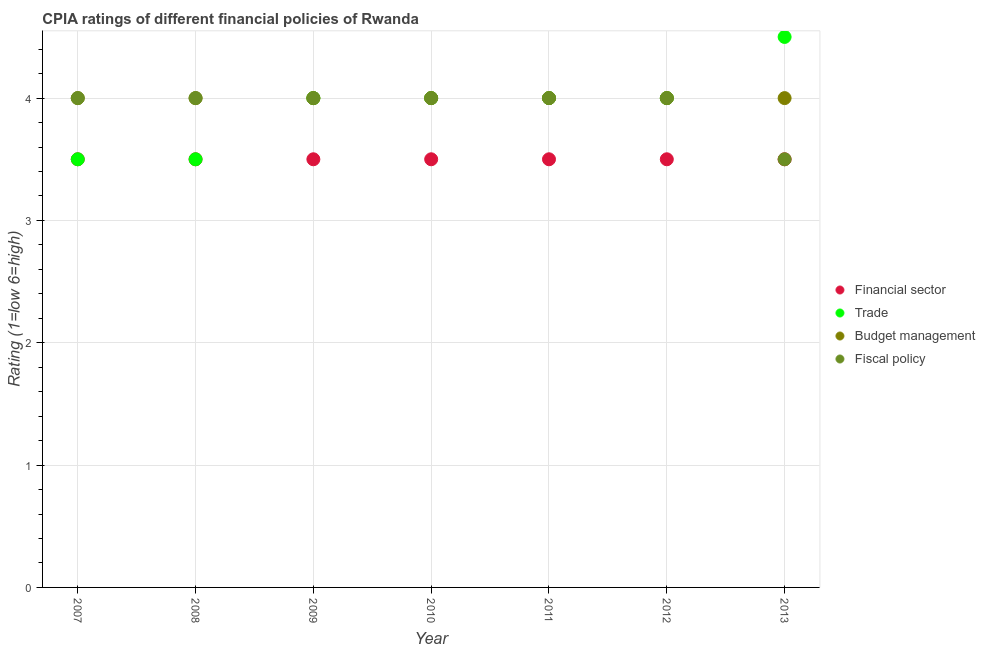How many different coloured dotlines are there?
Your response must be concise. 4. Across all years, what is the minimum cpia rating of trade?
Offer a terse response. 3.5. In which year was the cpia rating of budget management maximum?
Offer a very short reply. 2007. What is the average cpia rating of fiscal policy per year?
Make the answer very short. 3.93. Is it the case that in every year, the sum of the cpia rating of fiscal policy and cpia rating of trade is greater than the sum of cpia rating of financial sector and cpia rating of budget management?
Ensure brevity in your answer.  No. Is it the case that in every year, the sum of the cpia rating of financial sector and cpia rating of trade is greater than the cpia rating of budget management?
Your response must be concise. Yes. Is the cpia rating of fiscal policy strictly greater than the cpia rating of trade over the years?
Your answer should be very brief. No. Is the cpia rating of financial sector strictly less than the cpia rating of fiscal policy over the years?
Ensure brevity in your answer.  No. How many years are there in the graph?
Offer a very short reply. 7. What is the difference between two consecutive major ticks on the Y-axis?
Keep it short and to the point. 1. Does the graph contain any zero values?
Make the answer very short. No. Does the graph contain grids?
Offer a very short reply. Yes. Where does the legend appear in the graph?
Make the answer very short. Center right. What is the title of the graph?
Keep it short and to the point. CPIA ratings of different financial policies of Rwanda. Does "Minerals" appear as one of the legend labels in the graph?
Ensure brevity in your answer.  No. What is the label or title of the X-axis?
Your answer should be compact. Year. What is the label or title of the Y-axis?
Your answer should be very brief. Rating (1=low 6=high). What is the Rating (1=low 6=high) of Trade in 2007?
Your answer should be compact. 3.5. What is the Rating (1=low 6=high) in Fiscal policy in 2007?
Your response must be concise. 4. What is the Rating (1=low 6=high) of Fiscal policy in 2008?
Provide a short and direct response. 4. What is the Rating (1=low 6=high) of Trade in 2009?
Keep it short and to the point. 4. What is the Rating (1=low 6=high) of Fiscal policy in 2009?
Keep it short and to the point. 4. What is the Rating (1=low 6=high) of Trade in 2010?
Ensure brevity in your answer.  4. What is the Rating (1=low 6=high) in Fiscal policy in 2010?
Make the answer very short. 4. What is the Rating (1=low 6=high) in Trade in 2012?
Provide a short and direct response. 4. What is the Rating (1=low 6=high) in Budget management in 2013?
Offer a terse response. 4. Across all years, what is the minimum Rating (1=low 6=high) in Fiscal policy?
Your answer should be compact. 3.5. What is the total Rating (1=low 6=high) of Trade in the graph?
Provide a short and direct response. 27.5. What is the total Rating (1=low 6=high) of Budget management in the graph?
Keep it short and to the point. 28. What is the total Rating (1=low 6=high) of Fiscal policy in the graph?
Ensure brevity in your answer.  27.5. What is the difference between the Rating (1=low 6=high) in Financial sector in 2007 and that in 2008?
Provide a succinct answer. 0. What is the difference between the Rating (1=low 6=high) in Trade in 2007 and that in 2008?
Your answer should be very brief. 0. What is the difference between the Rating (1=low 6=high) of Budget management in 2007 and that in 2008?
Keep it short and to the point. 0. What is the difference between the Rating (1=low 6=high) in Fiscal policy in 2007 and that in 2008?
Keep it short and to the point. 0. What is the difference between the Rating (1=low 6=high) in Financial sector in 2007 and that in 2009?
Provide a short and direct response. 0. What is the difference between the Rating (1=low 6=high) of Trade in 2007 and that in 2009?
Your answer should be very brief. -0.5. What is the difference between the Rating (1=low 6=high) in Fiscal policy in 2007 and that in 2009?
Offer a very short reply. 0. What is the difference between the Rating (1=low 6=high) of Budget management in 2007 and that in 2011?
Your answer should be compact. 0. What is the difference between the Rating (1=low 6=high) in Trade in 2007 and that in 2012?
Give a very brief answer. -0.5. What is the difference between the Rating (1=low 6=high) of Financial sector in 2007 and that in 2013?
Give a very brief answer. 0. What is the difference between the Rating (1=low 6=high) of Trade in 2007 and that in 2013?
Your answer should be compact. -1. What is the difference between the Rating (1=low 6=high) of Budget management in 2008 and that in 2009?
Ensure brevity in your answer.  0. What is the difference between the Rating (1=low 6=high) of Fiscal policy in 2008 and that in 2009?
Offer a terse response. 0. What is the difference between the Rating (1=low 6=high) in Financial sector in 2008 and that in 2010?
Provide a short and direct response. 0. What is the difference between the Rating (1=low 6=high) in Budget management in 2008 and that in 2010?
Your answer should be very brief. 0. What is the difference between the Rating (1=low 6=high) of Financial sector in 2008 and that in 2011?
Keep it short and to the point. 0. What is the difference between the Rating (1=low 6=high) of Budget management in 2008 and that in 2011?
Your response must be concise. 0. What is the difference between the Rating (1=low 6=high) in Trade in 2008 and that in 2012?
Provide a short and direct response. -0.5. What is the difference between the Rating (1=low 6=high) in Budget management in 2008 and that in 2012?
Make the answer very short. 0. What is the difference between the Rating (1=low 6=high) in Financial sector in 2009 and that in 2010?
Ensure brevity in your answer.  0. What is the difference between the Rating (1=low 6=high) in Financial sector in 2009 and that in 2011?
Provide a short and direct response. 0. What is the difference between the Rating (1=low 6=high) in Budget management in 2009 and that in 2011?
Offer a terse response. 0. What is the difference between the Rating (1=low 6=high) of Fiscal policy in 2009 and that in 2011?
Your answer should be very brief. 0. What is the difference between the Rating (1=low 6=high) of Financial sector in 2009 and that in 2012?
Make the answer very short. 0. What is the difference between the Rating (1=low 6=high) of Budget management in 2009 and that in 2012?
Your answer should be compact. 0. What is the difference between the Rating (1=low 6=high) in Fiscal policy in 2009 and that in 2012?
Offer a terse response. 0. What is the difference between the Rating (1=low 6=high) in Financial sector in 2009 and that in 2013?
Provide a short and direct response. 0. What is the difference between the Rating (1=low 6=high) in Budget management in 2009 and that in 2013?
Offer a terse response. 0. What is the difference between the Rating (1=low 6=high) in Financial sector in 2010 and that in 2012?
Your response must be concise. 0. What is the difference between the Rating (1=low 6=high) in Trade in 2010 and that in 2012?
Your response must be concise. 0. What is the difference between the Rating (1=low 6=high) in Trade in 2010 and that in 2013?
Ensure brevity in your answer.  -0.5. What is the difference between the Rating (1=low 6=high) of Budget management in 2010 and that in 2013?
Ensure brevity in your answer.  0. What is the difference between the Rating (1=low 6=high) of Fiscal policy in 2010 and that in 2013?
Ensure brevity in your answer.  0.5. What is the difference between the Rating (1=low 6=high) in Financial sector in 2011 and that in 2012?
Keep it short and to the point. 0. What is the difference between the Rating (1=low 6=high) of Fiscal policy in 2011 and that in 2012?
Provide a short and direct response. 0. What is the difference between the Rating (1=low 6=high) of Financial sector in 2012 and that in 2013?
Provide a succinct answer. 0. What is the difference between the Rating (1=low 6=high) in Financial sector in 2007 and the Rating (1=low 6=high) in Trade in 2008?
Make the answer very short. 0. What is the difference between the Rating (1=low 6=high) in Budget management in 2007 and the Rating (1=low 6=high) in Fiscal policy in 2008?
Give a very brief answer. 0. What is the difference between the Rating (1=low 6=high) of Financial sector in 2007 and the Rating (1=low 6=high) of Trade in 2009?
Provide a short and direct response. -0.5. What is the difference between the Rating (1=low 6=high) in Financial sector in 2007 and the Rating (1=low 6=high) in Budget management in 2009?
Offer a very short reply. -0.5. What is the difference between the Rating (1=low 6=high) in Trade in 2007 and the Rating (1=low 6=high) in Fiscal policy in 2009?
Give a very brief answer. -0.5. What is the difference between the Rating (1=low 6=high) of Financial sector in 2007 and the Rating (1=low 6=high) of Fiscal policy in 2010?
Your answer should be compact. -0.5. What is the difference between the Rating (1=low 6=high) of Trade in 2007 and the Rating (1=low 6=high) of Fiscal policy in 2010?
Ensure brevity in your answer.  -0.5. What is the difference between the Rating (1=low 6=high) in Budget management in 2007 and the Rating (1=low 6=high) in Fiscal policy in 2010?
Offer a terse response. 0. What is the difference between the Rating (1=low 6=high) in Financial sector in 2007 and the Rating (1=low 6=high) in Fiscal policy in 2011?
Your response must be concise. -0.5. What is the difference between the Rating (1=low 6=high) of Trade in 2007 and the Rating (1=low 6=high) of Budget management in 2011?
Provide a succinct answer. -0.5. What is the difference between the Rating (1=low 6=high) of Financial sector in 2007 and the Rating (1=low 6=high) of Trade in 2012?
Keep it short and to the point. -0.5. What is the difference between the Rating (1=low 6=high) of Financial sector in 2007 and the Rating (1=low 6=high) of Trade in 2013?
Offer a very short reply. -1. What is the difference between the Rating (1=low 6=high) in Trade in 2007 and the Rating (1=low 6=high) in Budget management in 2013?
Keep it short and to the point. -0.5. What is the difference between the Rating (1=low 6=high) in Trade in 2007 and the Rating (1=low 6=high) in Fiscal policy in 2013?
Offer a terse response. 0. What is the difference between the Rating (1=low 6=high) of Financial sector in 2008 and the Rating (1=low 6=high) of Budget management in 2009?
Give a very brief answer. -0.5. What is the difference between the Rating (1=low 6=high) in Financial sector in 2008 and the Rating (1=low 6=high) in Fiscal policy in 2009?
Ensure brevity in your answer.  -0.5. What is the difference between the Rating (1=low 6=high) of Trade in 2008 and the Rating (1=low 6=high) of Budget management in 2009?
Offer a very short reply. -0.5. What is the difference between the Rating (1=low 6=high) of Trade in 2008 and the Rating (1=low 6=high) of Fiscal policy in 2009?
Provide a succinct answer. -0.5. What is the difference between the Rating (1=low 6=high) of Budget management in 2008 and the Rating (1=low 6=high) of Fiscal policy in 2009?
Keep it short and to the point. 0. What is the difference between the Rating (1=low 6=high) of Financial sector in 2008 and the Rating (1=low 6=high) of Budget management in 2010?
Provide a succinct answer. -0.5. What is the difference between the Rating (1=low 6=high) in Financial sector in 2008 and the Rating (1=low 6=high) in Fiscal policy in 2010?
Make the answer very short. -0.5. What is the difference between the Rating (1=low 6=high) in Trade in 2008 and the Rating (1=low 6=high) in Budget management in 2010?
Your answer should be very brief. -0.5. What is the difference between the Rating (1=low 6=high) in Trade in 2008 and the Rating (1=low 6=high) in Fiscal policy in 2010?
Offer a very short reply. -0.5. What is the difference between the Rating (1=low 6=high) of Financial sector in 2008 and the Rating (1=low 6=high) of Budget management in 2011?
Offer a very short reply. -0.5. What is the difference between the Rating (1=low 6=high) of Financial sector in 2008 and the Rating (1=low 6=high) of Fiscal policy in 2011?
Give a very brief answer. -0.5. What is the difference between the Rating (1=low 6=high) in Trade in 2008 and the Rating (1=low 6=high) in Budget management in 2011?
Ensure brevity in your answer.  -0.5. What is the difference between the Rating (1=low 6=high) of Financial sector in 2008 and the Rating (1=low 6=high) of Trade in 2012?
Your answer should be very brief. -0.5. What is the difference between the Rating (1=low 6=high) in Trade in 2008 and the Rating (1=low 6=high) in Fiscal policy in 2012?
Keep it short and to the point. -0.5. What is the difference between the Rating (1=low 6=high) in Budget management in 2008 and the Rating (1=low 6=high) in Fiscal policy in 2012?
Give a very brief answer. 0. What is the difference between the Rating (1=low 6=high) of Financial sector in 2008 and the Rating (1=low 6=high) of Trade in 2013?
Offer a very short reply. -1. What is the difference between the Rating (1=low 6=high) in Financial sector in 2008 and the Rating (1=low 6=high) in Budget management in 2013?
Offer a terse response. -0.5. What is the difference between the Rating (1=low 6=high) of Financial sector in 2008 and the Rating (1=low 6=high) of Fiscal policy in 2013?
Your answer should be compact. 0. What is the difference between the Rating (1=low 6=high) in Trade in 2008 and the Rating (1=low 6=high) in Budget management in 2013?
Make the answer very short. -0.5. What is the difference between the Rating (1=low 6=high) in Trade in 2008 and the Rating (1=low 6=high) in Fiscal policy in 2013?
Provide a succinct answer. 0. What is the difference between the Rating (1=low 6=high) in Budget management in 2008 and the Rating (1=low 6=high) in Fiscal policy in 2013?
Keep it short and to the point. 0.5. What is the difference between the Rating (1=low 6=high) of Financial sector in 2009 and the Rating (1=low 6=high) of Trade in 2010?
Provide a succinct answer. -0.5. What is the difference between the Rating (1=low 6=high) of Financial sector in 2009 and the Rating (1=low 6=high) of Budget management in 2010?
Your answer should be compact. -0.5. What is the difference between the Rating (1=low 6=high) of Financial sector in 2009 and the Rating (1=low 6=high) of Fiscal policy in 2010?
Keep it short and to the point. -0.5. What is the difference between the Rating (1=low 6=high) of Trade in 2009 and the Rating (1=low 6=high) of Fiscal policy in 2010?
Give a very brief answer. 0. What is the difference between the Rating (1=low 6=high) in Budget management in 2009 and the Rating (1=low 6=high) in Fiscal policy in 2010?
Offer a very short reply. 0. What is the difference between the Rating (1=low 6=high) in Financial sector in 2009 and the Rating (1=low 6=high) in Trade in 2011?
Offer a very short reply. -0.5. What is the difference between the Rating (1=low 6=high) of Budget management in 2009 and the Rating (1=low 6=high) of Fiscal policy in 2011?
Make the answer very short. 0. What is the difference between the Rating (1=low 6=high) in Financial sector in 2009 and the Rating (1=low 6=high) in Trade in 2012?
Offer a terse response. -0.5. What is the difference between the Rating (1=low 6=high) in Trade in 2009 and the Rating (1=low 6=high) in Budget management in 2012?
Make the answer very short. 0. What is the difference between the Rating (1=low 6=high) of Trade in 2009 and the Rating (1=low 6=high) of Fiscal policy in 2012?
Your answer should be very brief. 0. What is the difference between the Rating (1=low 6=high) in Budget management in 2009 and the Rating (1=low 6=high) in Fiscal policy in 2012?
Offer a very short reply. 0. What is the difference between the Rating (1=low 6=high) in Financial sector in 2009 and the Rating (1=low 6=high) in Trade in 2013?
Ensure brevity in your answer.  -1. What is the difference between the Rating (1=low 6=high) of Financial sector in 2009 and the Rating (1=low 6=high) of Fiscal policy in 2013?
Provide a short and direct response. 0. What is the difference between the Rating (1=low 6=high) in Trade in 2009 and the Rating (1=low 6=high) in Fiscal policy in 2013?
Your response must be concise. 0.5. What is the difference between the Rating (1=low 6=high) of Budget management in 2009 and the Rating (1=low 6=high) of Fiscal policy in 2013?
Offer a very short reply. 0.5. What is the difference between the Rating (1=low 6=high) in Financial sector in 2010 and the Rating (1=low 6=high) in Trade in 2011?
Keep it short and to the point. -0.5. What is the difference between the Rating (1=low 6=high) in Financial sector in 2010 and the Rating (1=low 6=high) in Fiscal policy in 2011?
Provide a short and direct response. -0.5. What is the difference between the Rating (1=low 6=high) in Trade in 2010 and the Rating (1=low 6=high) in Budget management in 2011?
Give a very brief answer. 0. What is the difference between the Rating (1=low 6=high) of Financial sector in 2010 and the Rating (1=low 6=high) of Trade in 2012?
Make the answer very short. -0.5. What is the difference between the Rating (1=low 6=high) of Financial sector in 2010 and the Rating (1=low 6=high) of Budget management in 2012?
Your response must be concise. -0.5. What is the difference between the Rating (1=low 6=high) in Trade in 2010 and the Rating (1=low 6=high) in Fiscal policy in 2012?
Provide a short and direct response. 0. What is the difference between the Rating (1=low 6=high) in Financial sector in 2010 and the Rating (1=low 6=high) in Trade in 2013?
Your response must be concise. -1. What is the difference between the Rating (1=low 6=high) of Financial sector in 2010 and the Rating (1=low 6=high) of Fiscal policy in 2013?
Provide a succinct answer. 0. What is the difference between the Rating (1=low 6=high) of Trade in 2010 and the Rating (1=low 6=high) of Fiscal policy in 2013?
Ensure brevity in your answer.  0.5. What is the difference between the Rating (1=low 6=high) in Financial sector in 2011 and the Rating (1=low 6=high) in Trade in 2012?
Your answer should be compact. -0.5. What is the difference between the Rating (1=low 6=high) in Financial sector in 2011 and the Rating (1=low 6=high) in Budget management in 2012?
Keep it short and to the point. -0.5. What is the difference between the Rating (1=low 6=high) in Financial sector in 2011 and the Rating (1=low 6=high) in Fiscal policy in 2012?
Your answer should be compact. -0.5. What is the difference between the Rating (1=low 6=high) in Trade in 2011 and the Rating (1=low 6=high) in Budget management in 2012?
Provide a succinct answer. 0. What is the difference between the Rating (1=low 6=high) in Budget management in 2011 and the Rating (1=low 6=high) in Fiscal policy in 2012?
Ensure brevity in your answer.  0. What is the difference between the Rating (1=low 6=high) in Financial sector in 2011 and the Rating (1=low 6=high) in Trade in 2013?
Offer a very short reply. -1. What is the difference between the Rating (1=low 6=high) of Trade in 2011 and the Rating (1=low 6=high) of Budget management in 2013?
Give a very brief answer. 0. What is the difference between the Rating (1=low 6=high) of Trade in 2012 and the Rating (1=low 6=high) of Budget management in 2013?
Give a very brief answer. 0. What is the difference between the Rating (1=low 6=high) of Budget management in 2012 and the Rating (1=low 6=high) of Fiscal policy in 2013?
Provide a short and direct response. 0.5. What is the average Rating (1=low 6=high) of Trade per year?
Give a very brief answer. 3.93. What is the average Rating (1=low 6=high) of Fiscal policy per year?
Offer a very short reply. 3.93. In the year 2007, what is the difference between the Rating (1=low 6=high) in Financial sector and Rating (1=low 6=high) in Budget management?
Your response must be concise. -0.5. In the year 2007, what is the difference between the Rating (1=low 6=high) in Trade and Rating (1=low 6=high) in Fiscal policy?
Offer a very short reply. -0.5. In the year 2007, what is the difference between the Rating (1=low 6=high) in Budget management and Rating (1=low 6=high) in Fiscal policy?
Offer a terse response. 0. In the year 2008, what is the difference between the Rating (1=low 6=high) in Trade and Rating (1=low 6=high) in Budget management?
Ensure brevity in your answer.  -0.5. In the year 2009, what is the difference between the Rating (1=low 6=high) of Financial sector and Rating (1=low 6=high) of Trade?
Give a very brief answer. -0.5. In the year 2009, what is the difference between the Rating (1=low 6=high) of Trade and Rating (1=low 6=high) of Fiscal policy?
Ensure brevity in your answer.  0. In the year 2010, what is the difference between the Rating (1=low 6=high) of Financial sector and Rating (1=low 6=high) of Fiscal policy?
Ensure brevity in your answer.  -0.5. In the year 2010, what is the difference between the Rating (1=low 6=high) in Budget management and Rating (1=low 6=high) in Fiscal policy?
Provide a succinct answer. 0. In the year 2011, what is the difference between the Rating (1=low 6=high) of Financial sector and Rating (1=low 6=high) of Fiscal policy?
Provide a short and direct response. -0.5. In the year 2011, what is the difference between the Rating (1=low 6=high) of Trade and Rating (1=low 6=high) of Fiscal policy?
Provide a short and direct response. 0. In the year 2012, what is the difference between the Rating (1=low 6=high) in Financial sector and Rating (1=low 6=high) in Trade?
Give a very brief answer. -0.5. In the year 2012, what is the difference between the Rating (1=low 6=high) in Financial sector and Rating (1=low 6=high) in Budget management?
Provide a succinct answer. -0.5. In the year 2012, what is the difference between the Rating (1=low 6=high) of Trade and Rating (1=low 6=high) of Budget management?
Keep it short and to the point. 0. In the year 2012, what is the difference between the Rating (1=low 6=high) in Trade and Rating (1=low 6=high) in Fiscal policy?
Your response must be concise. 0. In the year 2013, what is the difference between the Rating (1=low 6=high) in Financial sector and Rating (1=low 6=high) in Budget management?
Give a very brief answer. -0.5. In the year 2013, what is the difference between the Rating (1=low 6=high) in Trade and Rating (1=low 6=high) in Budget management?
Ensure brevity in your answer.  0.5. In the year 2013, what is the difference between the Rating (1=low 6=high) in Trade and Rating (1=low 6=high) in Fiscal policy?
Ensure brevity in your answer.  1. What is the ratio of the Rating (1=low 6=high) in Financial sector in 2007 to that in 2008?
Your answer should be very brief. 1. What is the ratio of the Rating (1=low 6=high) in Budget management in 2007 to that in 2008?
Provide a short and direct response. 1. What is the ratio of the Rating (1=low 6=high) of Financial sector in 2007 to that in 2009?
Ensure brevity in your answer.  1. What is the ratio of the Rating (1=low 6=high) of Financial sector in 2007 to that in 2010?
Give a very brief answer. 1. What is the ratio of the Rating (1=low 6=high) of Trade in 2007 to that in 2011?
Offer a terse response. 0.88. What is the ratio of the Rating (1=low 6=high) of Fiscal policy in 2007 to that in 2011?
Provide a short and direct response. 1. What is the ratio of the Rating (1=low 6=high) of Trade in 2007 to that in 2012?
Ensure brevity in your answer.  0.88. What is the ratio of the Rating (1=low 6=high) of Budget management in 2007 to that in 2012?
Your answer should be very brief. 1. What is the ratio of the Rating (1=low 6=high) of Financial sector in 2007 to that in 2013?
Make the answer very short. 1. What is the ratio of the Rating (1=low 6=high) in Fiscal policy in 2007 to that in 2013?
Your response must be concise. 1.14. What is the ratio of the Rating (1=low 6=high) of Budget management in 2008 to that in 2009?
Your answer should be very brief. 1. What is the ratio of the Rating (1=low 6=high) of Trade in 2008 to that in 2010?
Keep it short and to the point. 0.88. What is the ratio of the Rating (1=low 6=high) of Budget management in 2008 to that in 2010?
Your answer should be very brief. 1. What is the ratio of the Rating (1=low 6=high) of Fiscal policy in 2008 to that in 2010?
Make the answer very short. 1. What is the ratio of the Rating (1=low 6=high) in Financial sector in 2008 to that in 2011?
Provide a succinct answer. 1. What is the ratio of the Rating (1=low 6=high) of Trade in 2008 to that in 2011?
Provide a succinct answer. 0.88. What is the ratio of the Rating (1=low 6=high) in Budget management in 2008 to that in 2011?
Offer a terse response. 1. What is the ratio of the Rating (1=low 6=high) of Financial sector in 2008 to that in 2012?
Give a very brief answer. 1. What is the ratio of the Rating (1=low 6=high) of Budget management in 2008 to that in 2012?
Provide a short and direct response. 1. What is the ratio of the Rating (1=low 6=high) in Trade in 2008 to that in 2013?
Keep it short and to the point. 0.78. What is the ratio of the Rating (1=low 6=high) of Budget management in 2008 to that in 2013?
Your answer should be compact. 1. What is the ratio of the Rating (1=low 6=high) in Budget management in 2009 to that in 2010?
Ensure brevity in your answer.  1. What is the ratio of the Rating (1=low 6=high) in Trade in 2009 to that in 2011?
Ensure brevity in your answer.  1. What is the ratio of the Rating (1=low 6=high) in Budget management in 2009 to that in 2011?
Your answer should be compact. 1. What is the ratio of the Rating (1=low 6=high) in Fiscal policy in 2009 to that in 2011?
Provide a succinct answer. 1. What is the ratio of the Rating (1=low 6=high) of Financial sector in 2009 to that in 2012?
Provide a short and direct response. 1. What is the ratio of the Rating (1=low 6=high) of Trade in 2009 to that in 2012?
Ensure brevity in your answer.  1. What is the ratio of the Rating (1=low 6=high) in Budget management in 2009 to that in 2012?
Your response must be concise. 1. What is the ratio of the Rating (1=low 6=high) of Fiscal policy in 2009 to that in 2012?
Offer a very short reply. 1. What is the ratio of the Rating (1=low 6=high) of Financial sector in 2010 to that in 2011?
Give a very brief answer. 1. What is the ratio of the Rating (1=low 6=high) of Trade in 2010 to that in 2012?
Give a very brief answer. 1. What is the ratio of the Rating (1=low 6=high) of Financial sector in 2010 to that in 2013?
Give a very brief answer. 1. What is the ratio of the Rating (1=low 6=high) in Trade in 2010 to that in 2013?
Your answer should be very brief. 0.89. What is the ratio of the Rating (1=low 6=high) in Budget management in 2010 to that in 2013?
Offer a terse response. 1. What is the ratio of the Rating (1=low 6=high) in Financial sector in 2011 to that in 2012?
Make the answer very short. 1. What is the ratio of the Rating (1=low 6=high) in Budget management in 2011 to that in 2012?
Provide a succinct answer. 1. What is the ratio of the Rating (1=low 6=high) of Fiscal policy in 2011 to that in 2012?
Keep it short and to the point. 1. What is the ratio of the Rating (1=low 6=high) in Trade in 2011 to that in 2013?
Provide a succinct answer. 0.89. What is the ratio of the Rating (1=low 6=high) of Trade in 2012 to that in 2013?
Offer a terse response. 0.89. What is the ratio of the Rating (1=low 6=high) of Fiscal policy in 2012 to that in 2013?
Your answer should be very brief. 1.14. What is the difference between the highest and the second highest Rating (1=low 6=high) of Financial sector?
Provide a succinct answer. 0. What is the difference between the highest and the lowest Rating (1=low 6=high) of Trade?
Offer a terse response. 1. 